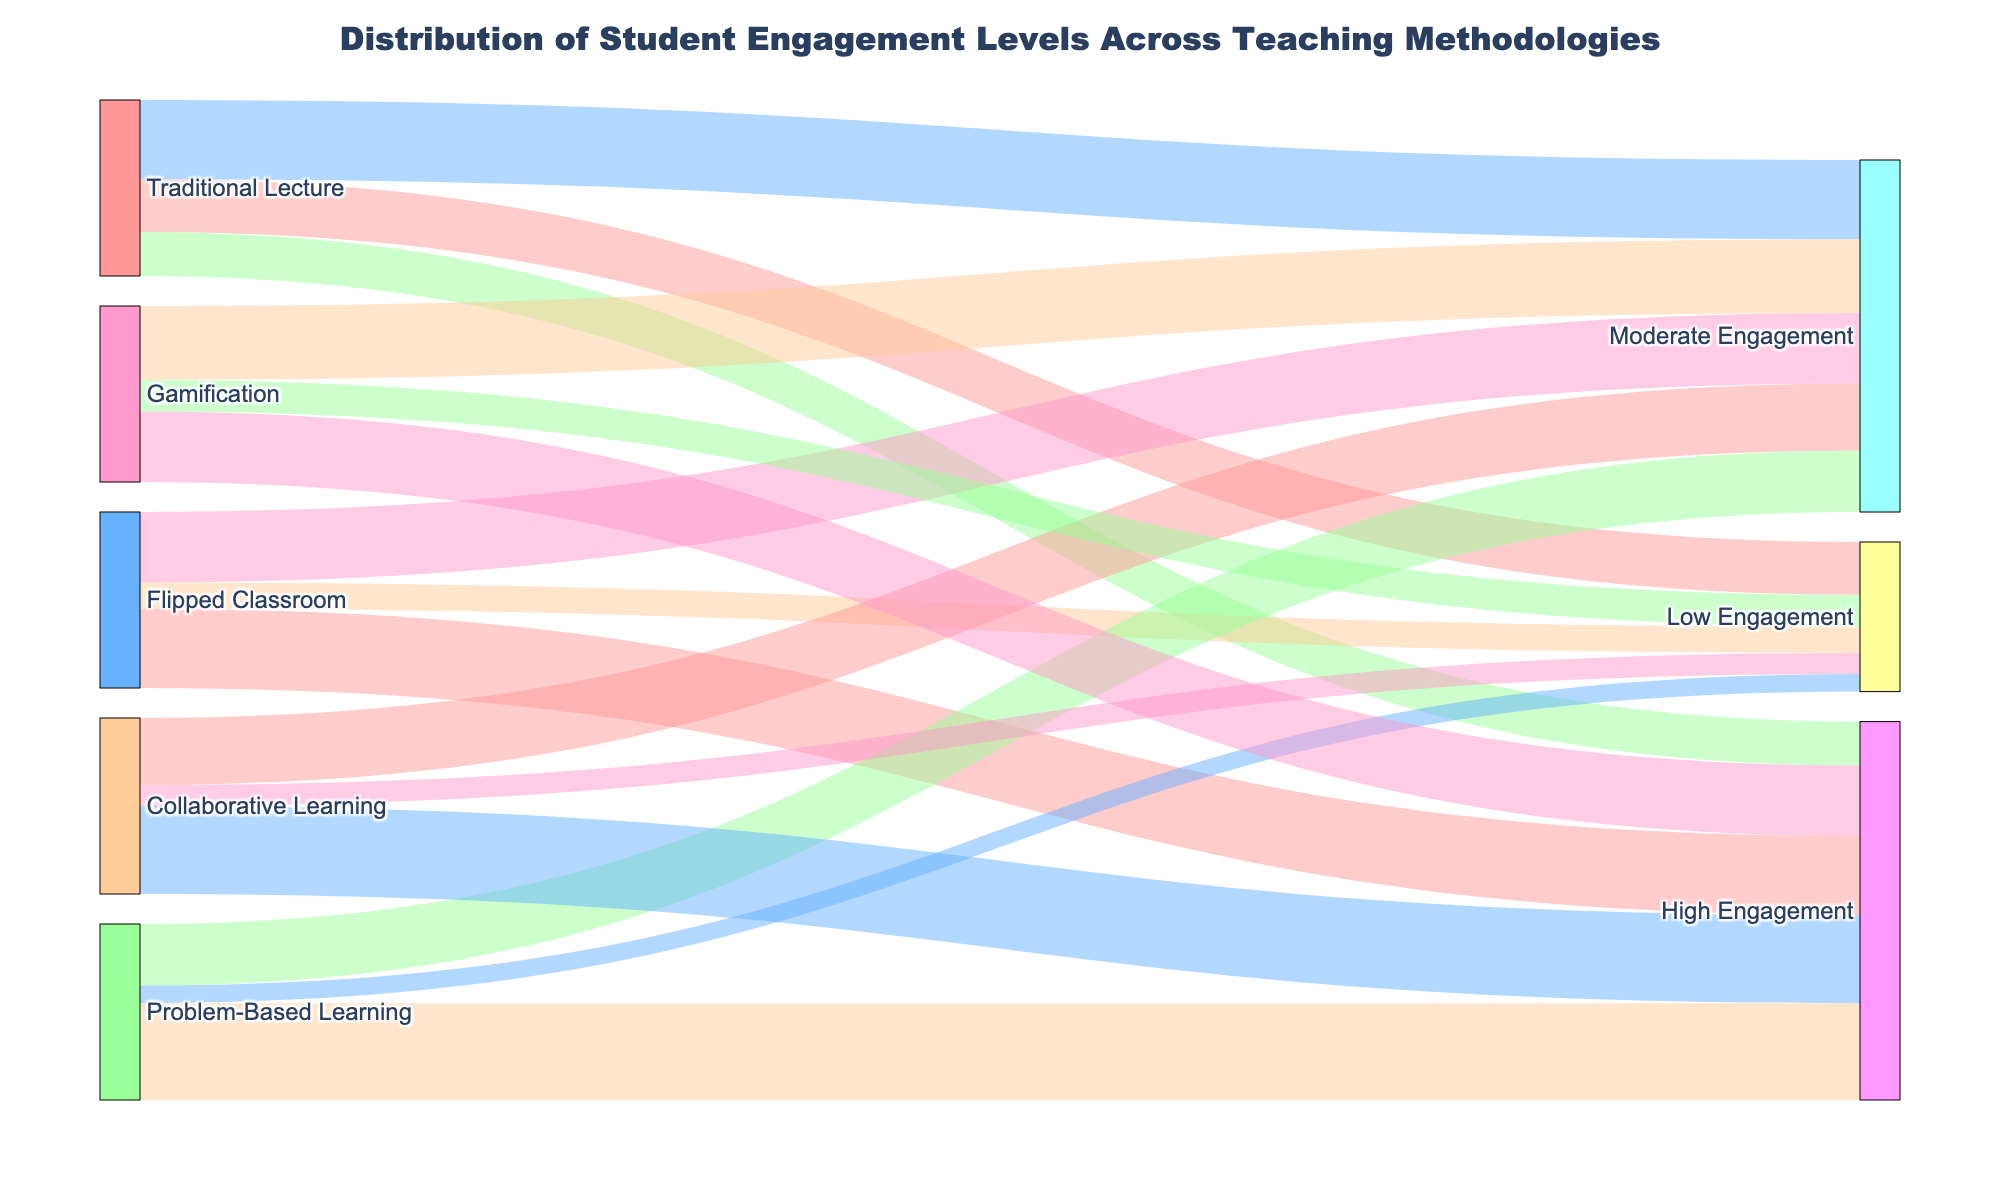What's the title of the Sankey Diagram? The title is shown at the top of the figure and provides context for the data presented in the diagram.
Answer: Distribution of Student Engagement Levels Across Teaching Methodologies How many teaching methodologies are represented in the Sankey Diagram? Each unique source in the data represents a different teaching methodology. Counting the unique sources will give the number of methodologies.
Answer: 5 Which teaching methodology has the highest number of students with high engagement? By examining the nodes and links, identify the methodology with the highest link value directed towards "High Engagement".
Answer: Problem-Based Learning Compare the engagement levels for Traditional Lecture and Flipped Classroom methodologies. Which has a higher high engagement students and by how much? Look at the values for "High Engagement" under both methodologies. Subtract the number linked to Traditional Lecture from the number linked to Flipped Classroom to find the difference.
Answer: Flipped Classroom has 20 more students with high engagement than Traditional Lecture What is the total number of students experiencing moderate engagement across all teaching methodologies? Sum up all the values linked to "Moderate Engagement" across the different sources.
Answer: 200 For Gamification, what percentage of students show low engagement? To find the percentage, take the number of students with "Low Engagement" and divide by the total number of students for Gamification, then multiply by 100.
Answer: 18% Which engagement level has the highest total number of students across all methodologies? Sum the values for Low, Moderate, and High Engagement across all methodologies to determine which level is the highest.
Answer: High Engagement How many students in total are engaged with Collaborative Learning? Sum the values of all engagement levels (Low, Moderate, High) for Collaborative Learning.
Answer: 100 Which teaching methodology has the least number of students showing low engagement? Compare the values linked to "Low Engagement" for each methodology and identify the smallest number.
Answer: Problem-Based Learning 